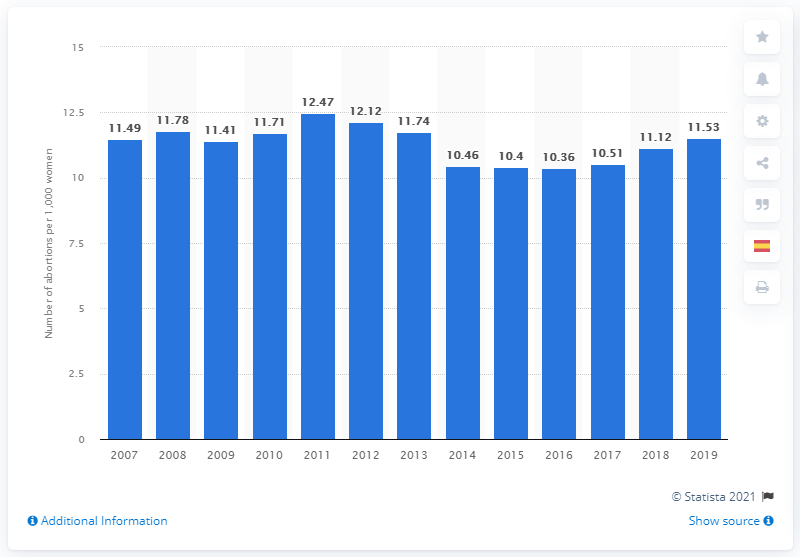Outline some significant characteristics in this image. The abortion rate in Spain was 10.4 from 2011 to 2016. 